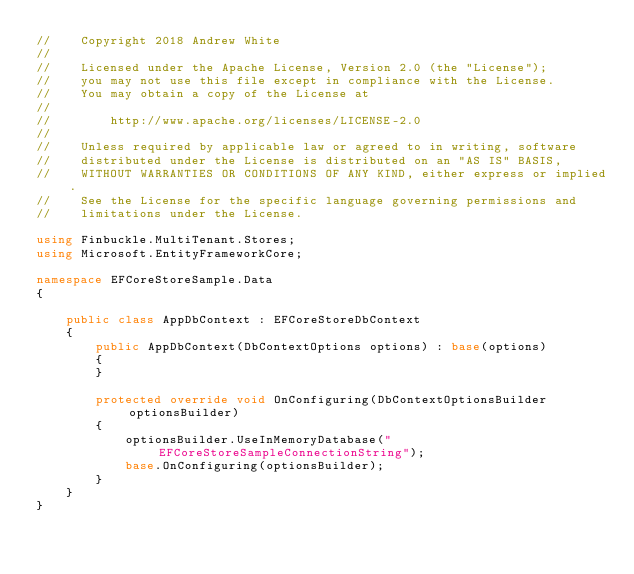Convert code to text. <code><loc_0><loc_0><loc_500><loc_500><_C#_>//    Copyright 2018 Andrew White
// 
//    Licensed under the Apache License, Version 2.0 (the "License");
//    you may not use this file except in compliance with the License.
//    You may obtain a copy of the License at
// 
//        http://www.apache.org/licenses/LICENSE-2.0
// 
//    Unless required by applicable law or agreed to in writing, software
//    distributed under the License is distributed on an "AS IS" BASIS,
//    WITHOUT WARRANTIES OR CONDITIONS OF ANY KIND, either express or implied.
//    See the License for the specific language governing permissions and
//    limitations under the License.

using Finbuckle.MultiTenant.Stores;
using Microsoft.EntityFrameworkCore;

namespace EFCoreStoreSample.Data
{

    public class AppDbContext : EFCoreStoreDbContext
    {
        public AppDbContext(DbContextOptions options) : base(options)
        {
        }

        protected override void OnConfiguring(DbContextOptionsBuilder optionsBuilder)
        {
            optionsBuilder.UseInMemoryDatabase("EFCoreStoreSampleConnectionString");
            base.OnConfiguring(optionsBuilder);
        }
    }
}</code> 